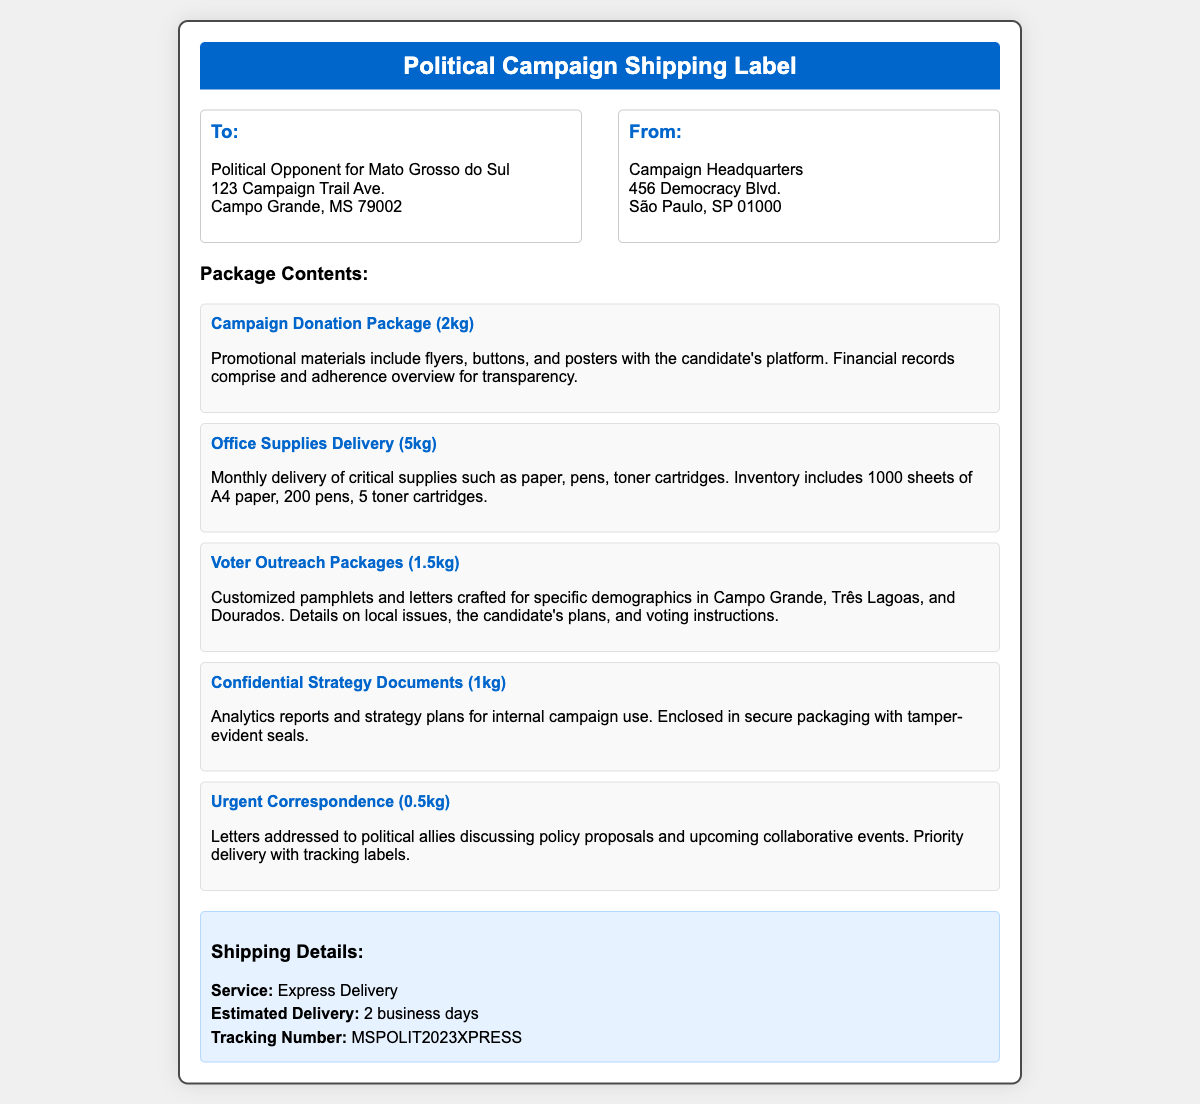What is the sender's address? The sender is Campaign Headquarters located at 456 Democracy Blvd., São Paulo, SP 01000.
Answer: 456 Democracy Blvd., São Paulo, SP 01000 What is the estimated delivery time? The document states that the estimated delivery is 2 business days.
Answer: 2 business days How many toner cartridges are included in the office supplies delivery? The office supplies section specifies that there are 5 toner cartridges.
Answer: 5 toner cartridges What is the weight of the urgent correspondence package? The document indicates that the weight of the urgent correspondence is 0.5 kg.
Answer: 0.5 kg What type of service is used for shipping? The shipping details mention that the service used is Express Delivery.
Answer: Express Delivery What items are included in the Campaign Donation Package? The contents mention promotional materials, including flyers, buttons, and posters.
Answer: Flyers, buttons, and posters How many pamphlets are intended for voter outreach? The document does not specify the number of pamphlets, only that they are customized for specific demographics.
Answer: Customized pamphlets What is the tracking number for the package? The shipping details state that the tracking number is MSPOLIT2023XPRESS.
Answer: MSPOLIT2023XPRESS What does the confidential package contain? The document states that the confidential package contains analytics reports and strategy plans for internal campaign use.
Answer: Analytics reports and strategy plans 